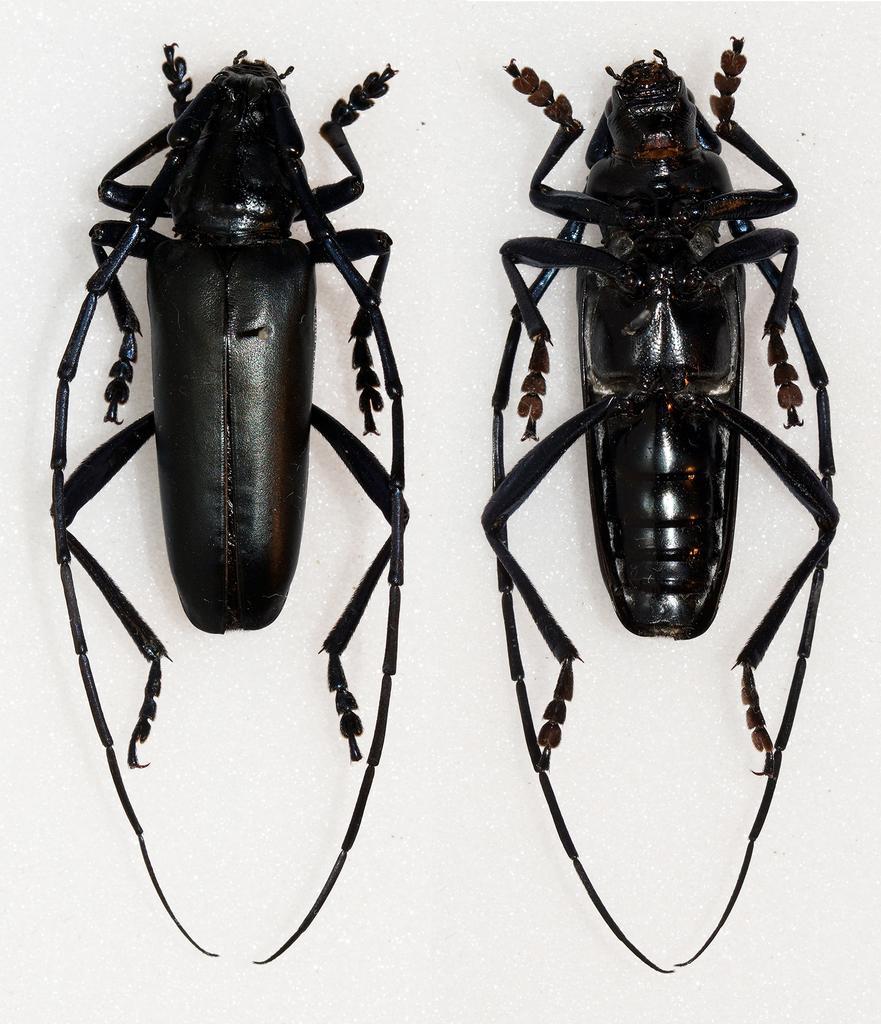Could you give a brief overview of what you see in this image? In this image I can see two cockroaches, they are in black color and I can see white color background. 